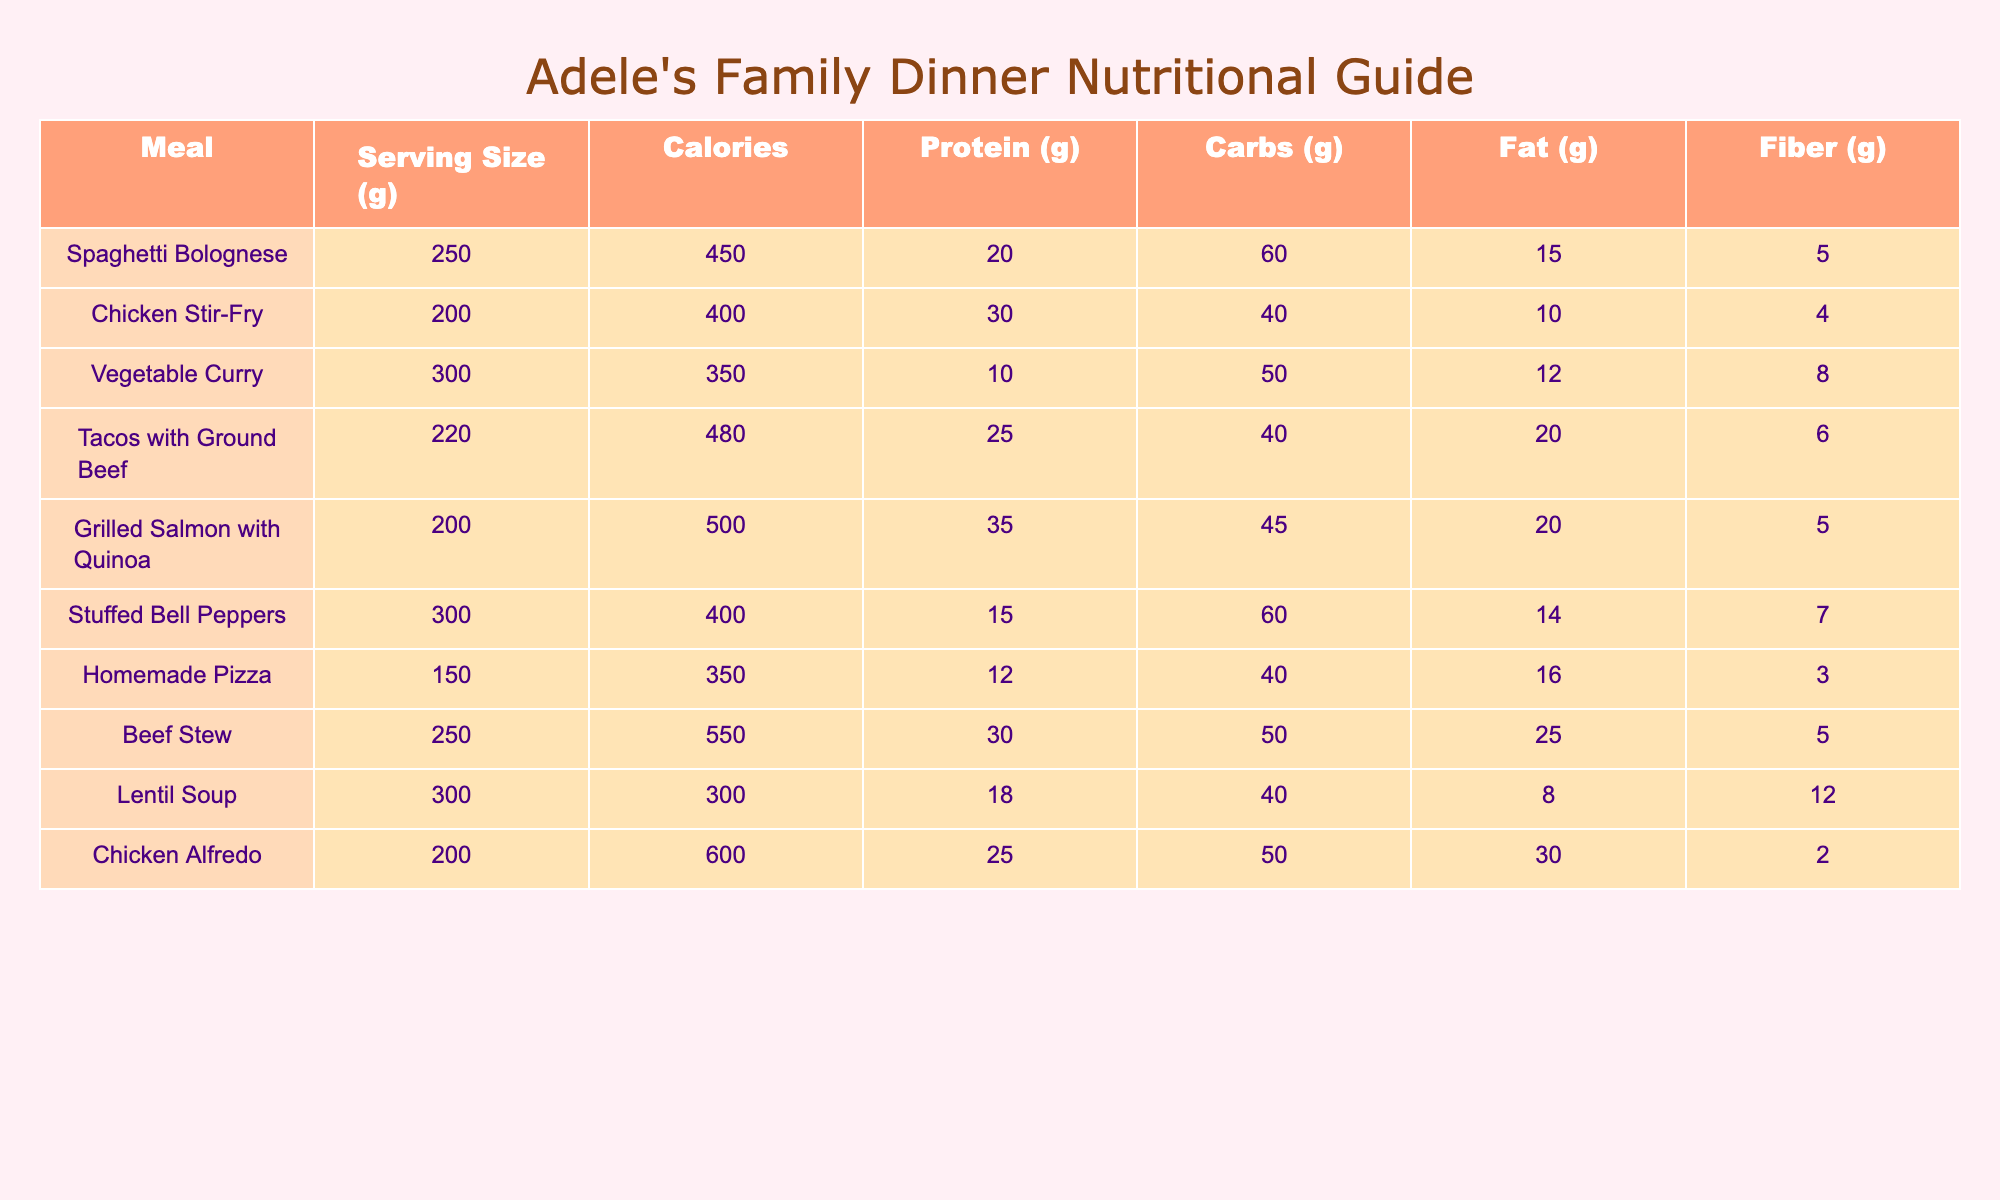What is the highest calorie meal in the table? The table lists the calories for each meal. Scanning through, Beef Stew has the highest calorie count at 550.
Answer: 550 Which meal has the most protein? By checking the protein values for all meals, Grilled Salmon with Quinoa has the highest protein content at 35 grams.
Answer: 35 grams What are the total carbohydrates for Spaghetti Bolognese and Chicken Stir-Fry combined? The carbohydrates for Spaghetti Bolognese is 60 grams and for Chicken Stir-Fry it is 40 grams. Adding them gives 60 + 40 = 100 grams.
Answer: 100 grams Does Vegetable Curry contain more carbs than Lentil Soup? Vegetable Curry has 50 grams of carbs, while Lentil Soup has 40 grams. Since 50 is greater than 40, the statement is true.
Answer: Yes What is the average fat content of Chicken Alfredo and Stuffed Bell Peppers? Chicken Alfredo has 30 grams of fat, and Stuffed Bell Peppers has 14 grams. To calculate the average: (30 + 14) / 2 = 22 grams.
Answer: 22 grams Is the calorie content of Tacos with Ground Beef greater than that of Homemade Pizza? Tacos with Ground Beef has 480 calories, while Homemade Pizza has 350 calories. Since 480 is greater than 350, the answer is yes.
Answer: Yes What is the total fiber content of Chicken Stir-Fry and Grilled Salmon with Quinoa? Chicken Stir-Fry has 4 grams of fiber and Grilled Salmon with Quinoa has 5 grams of fiber. Adding them gives 4 + 5 = 9 grams.
Answer: 9 grams Which meal has the least amount of calories? Looking at the calorie counts, Lentil Soup has the lowest calorie value at 300.
Answer: 300 What is the difference in protein content between Beef Stew and Tacos with Ground Beef? Beef Stew has 30 grams of protein and Tacos with Ground Beef has 25 grams. The difference is 30 - 25 = 5 grams.
Answer: 5 grams 